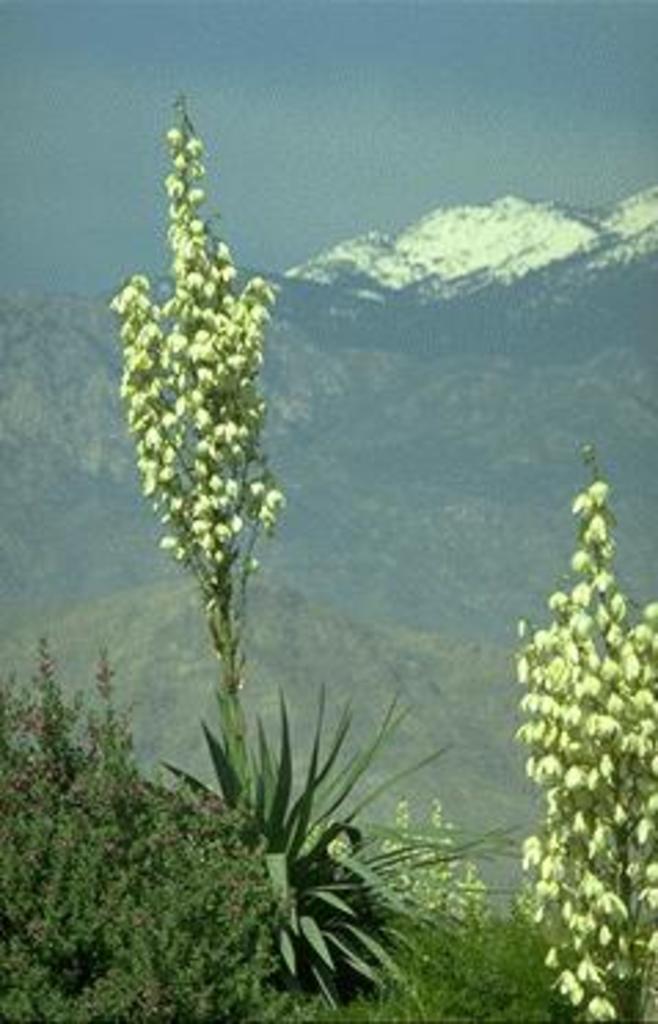Can you describe this image briefly? In the image there are plants in the foreground and in the background there are mountains. 